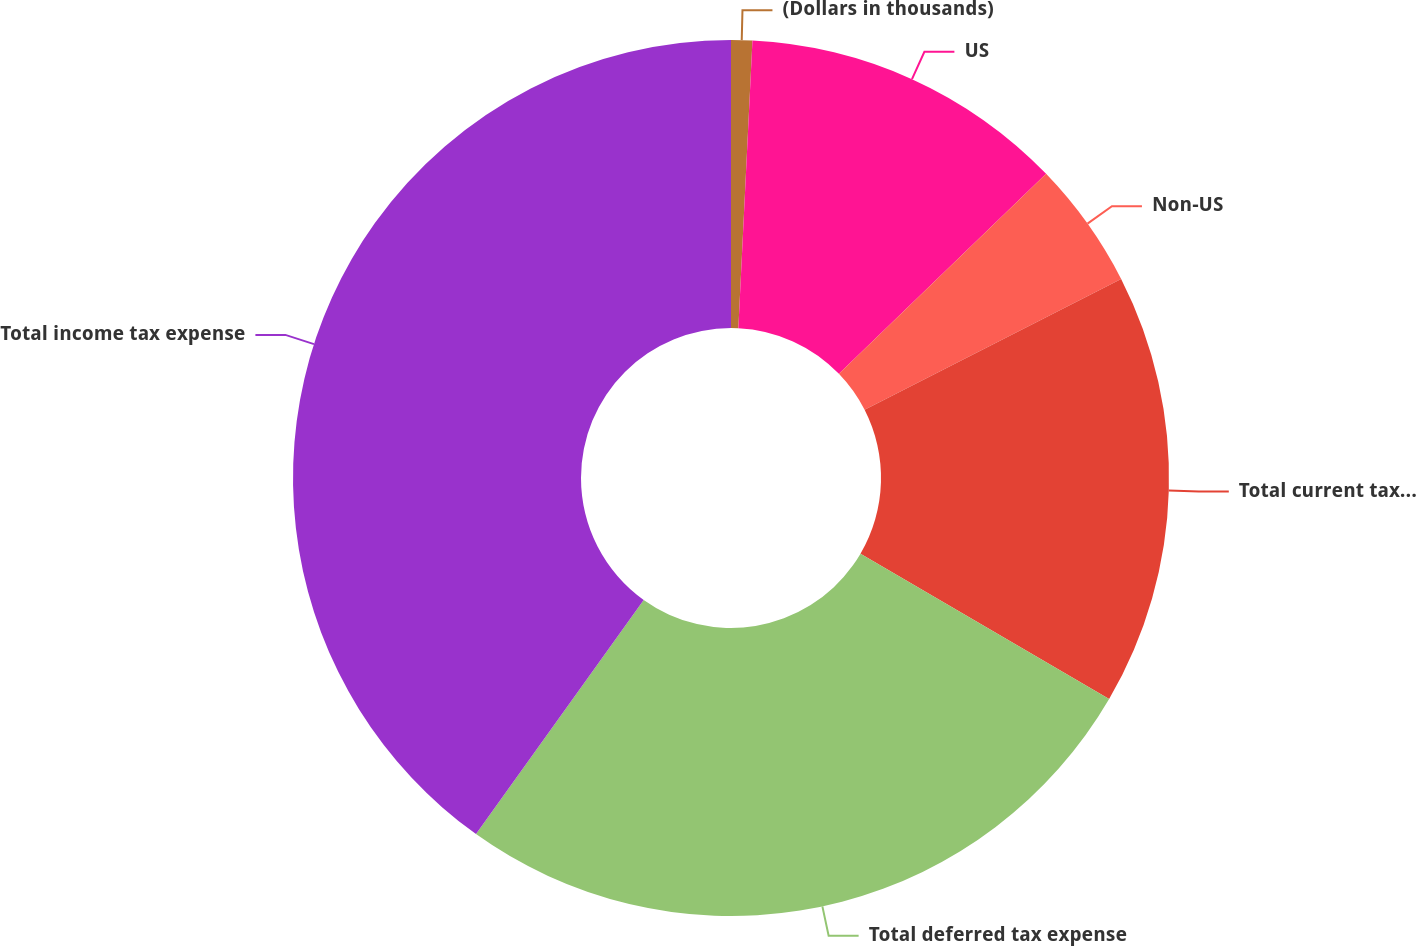Convert chart. <chart><loc_0><loc_0><loc_500><loc_500><pie_chart><fcel>(Dollars in thousands)<fcel>US<fcel>Non-US<fcel>Total current tax expense<fcel>Total deferred tax expense<fcel>Total income tax expense<nl><fcel>0.78%<fcel>12.0%<fcel>4.71%<fcel>15.93%<fcel>26.47%<fcel>40.11%<nl></chart> 